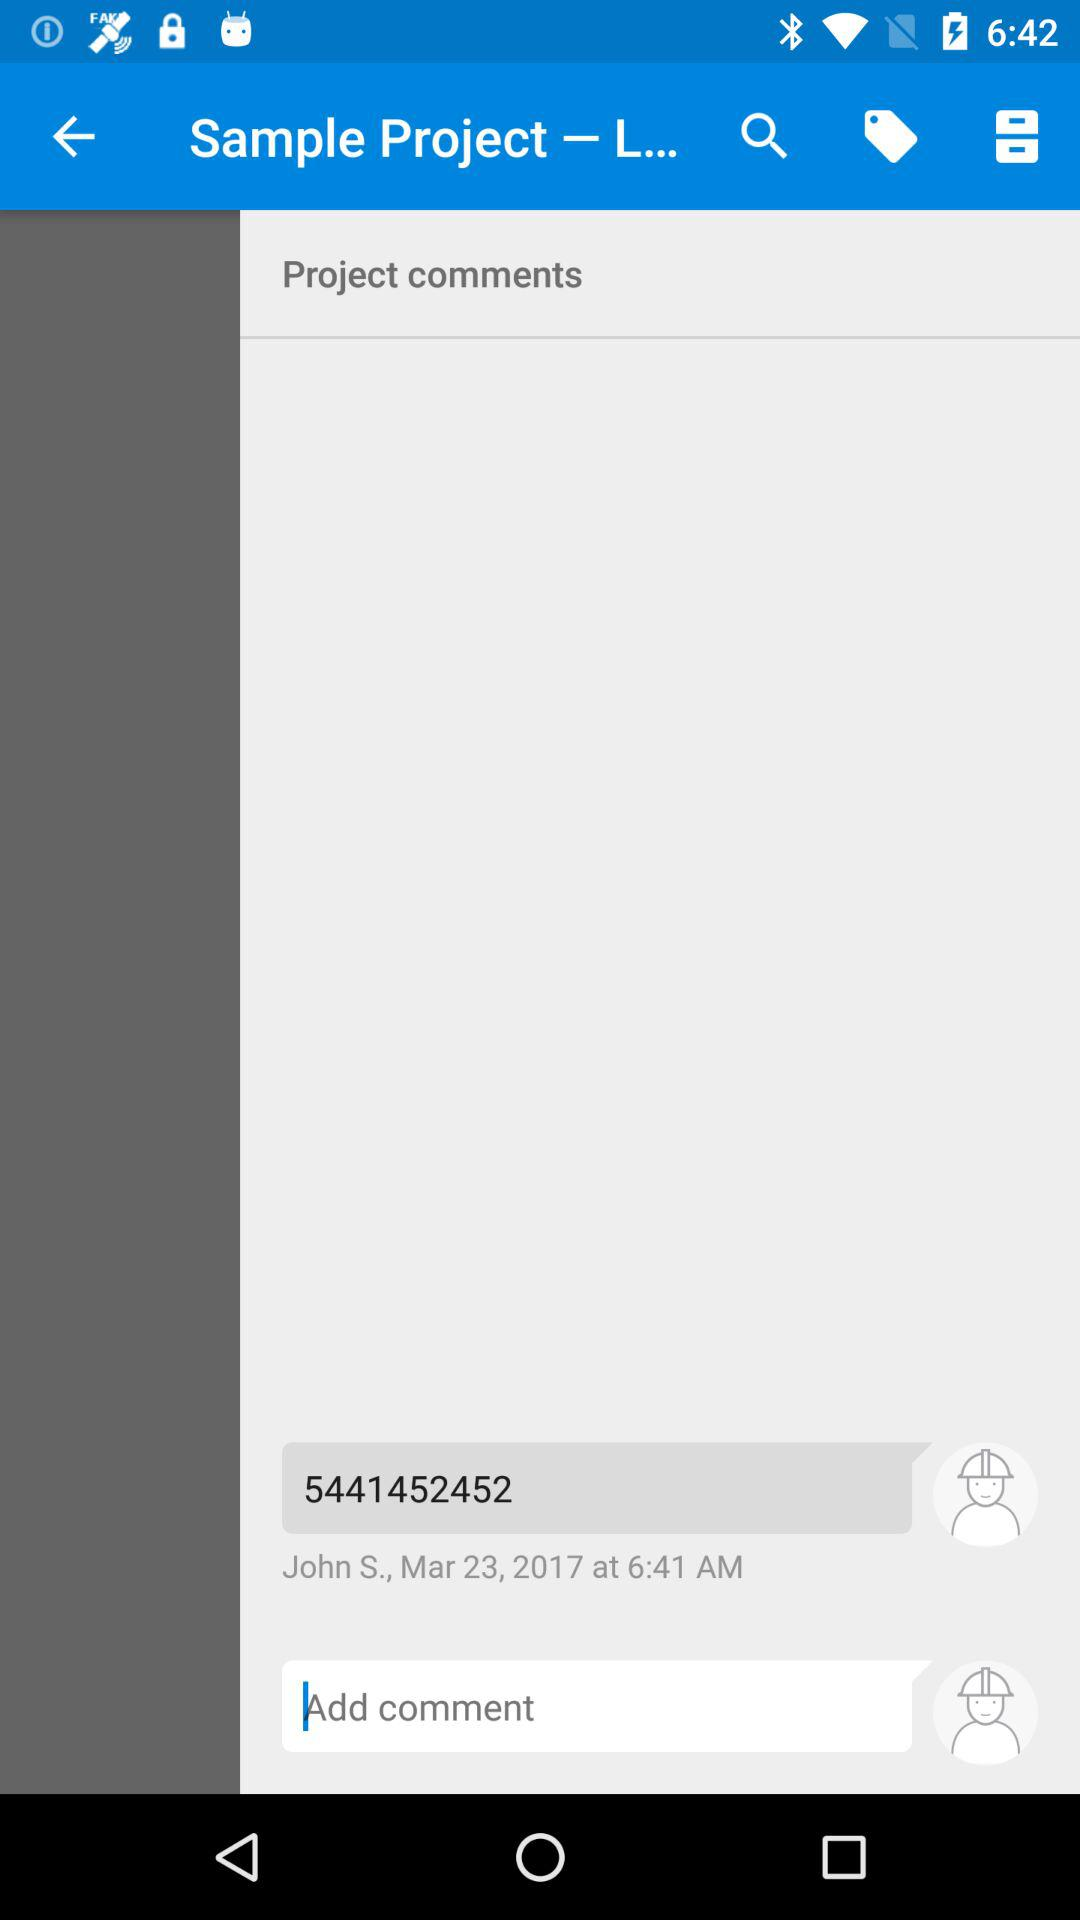On what date did John S. comment? John S. commented on March 23, 2017. 